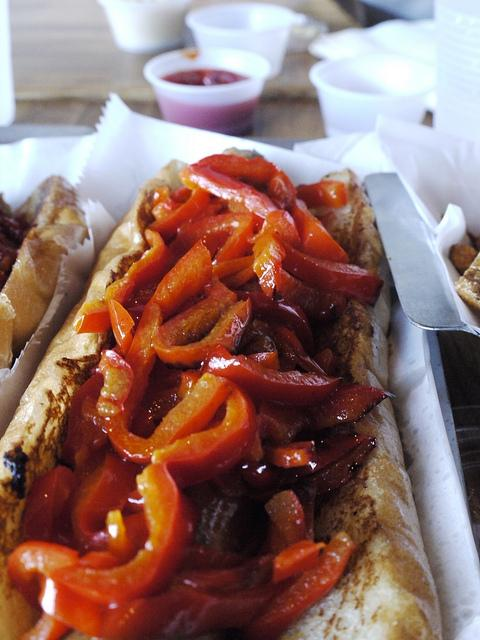What is on top of the sandwich?

Choices:
A) tater tots
B) red peppers
C) mustard
D) eggs red peppers 